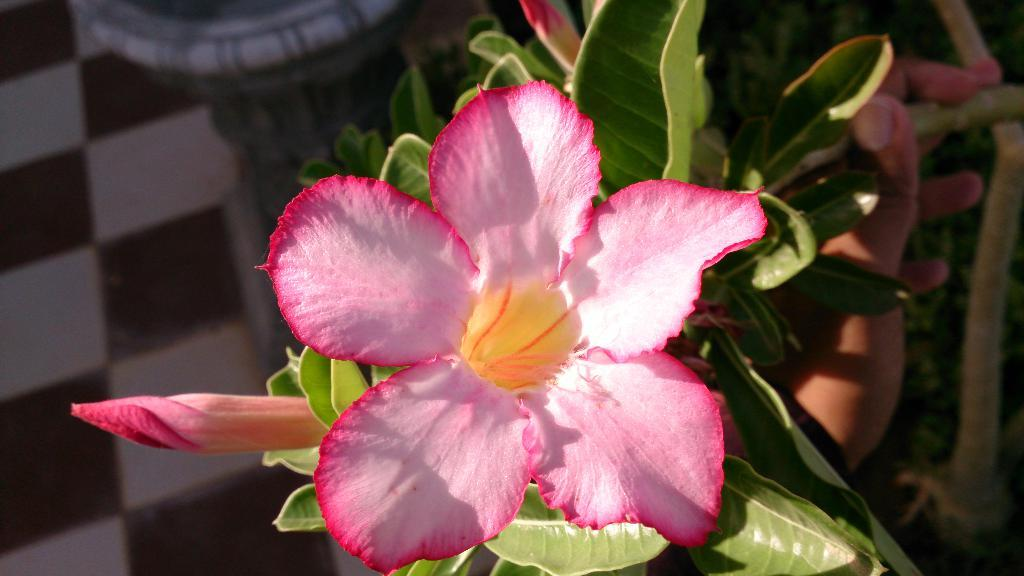What is the main subject in the front of the image? There is a flower in the front of the image. What can be seen in the background of the image? There are leaves in the background of the image. What is the hand holding in the image? There is holding a plant in the image. What is the scent of the place where the flower is located in the image? The provided facts do not mention any scent or place, so it cannot be determined from the image. 